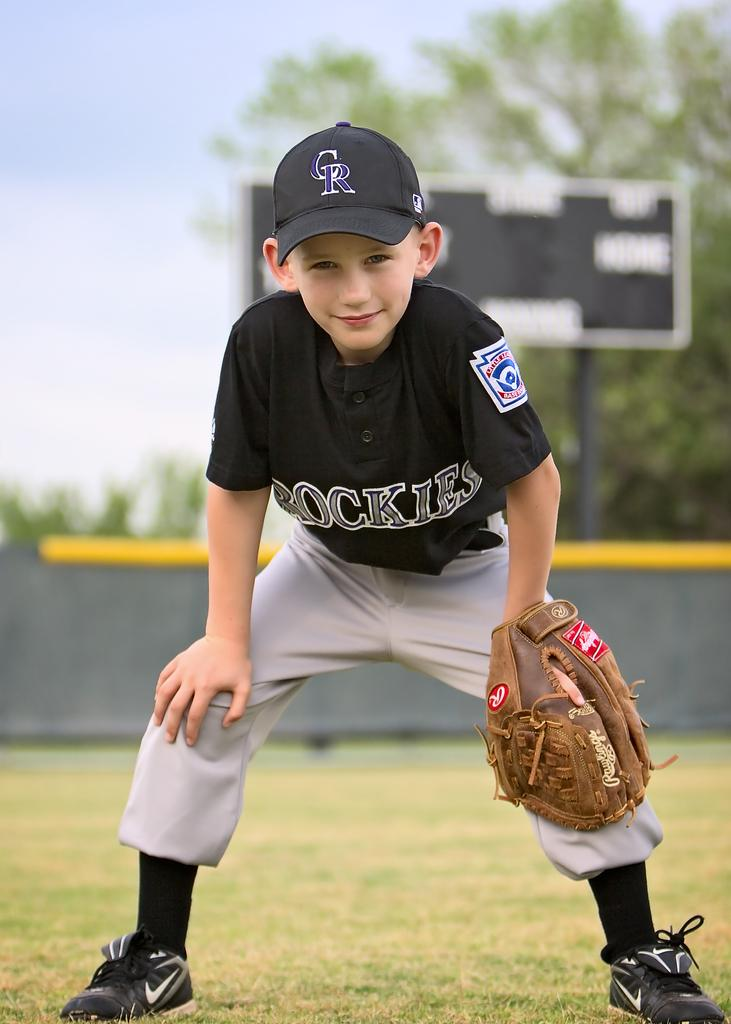<image>
Offer a succinct explanation of the picture presented. A little league baseball player dressed in a Colorado Rockies uniform with his hands on his knees. 